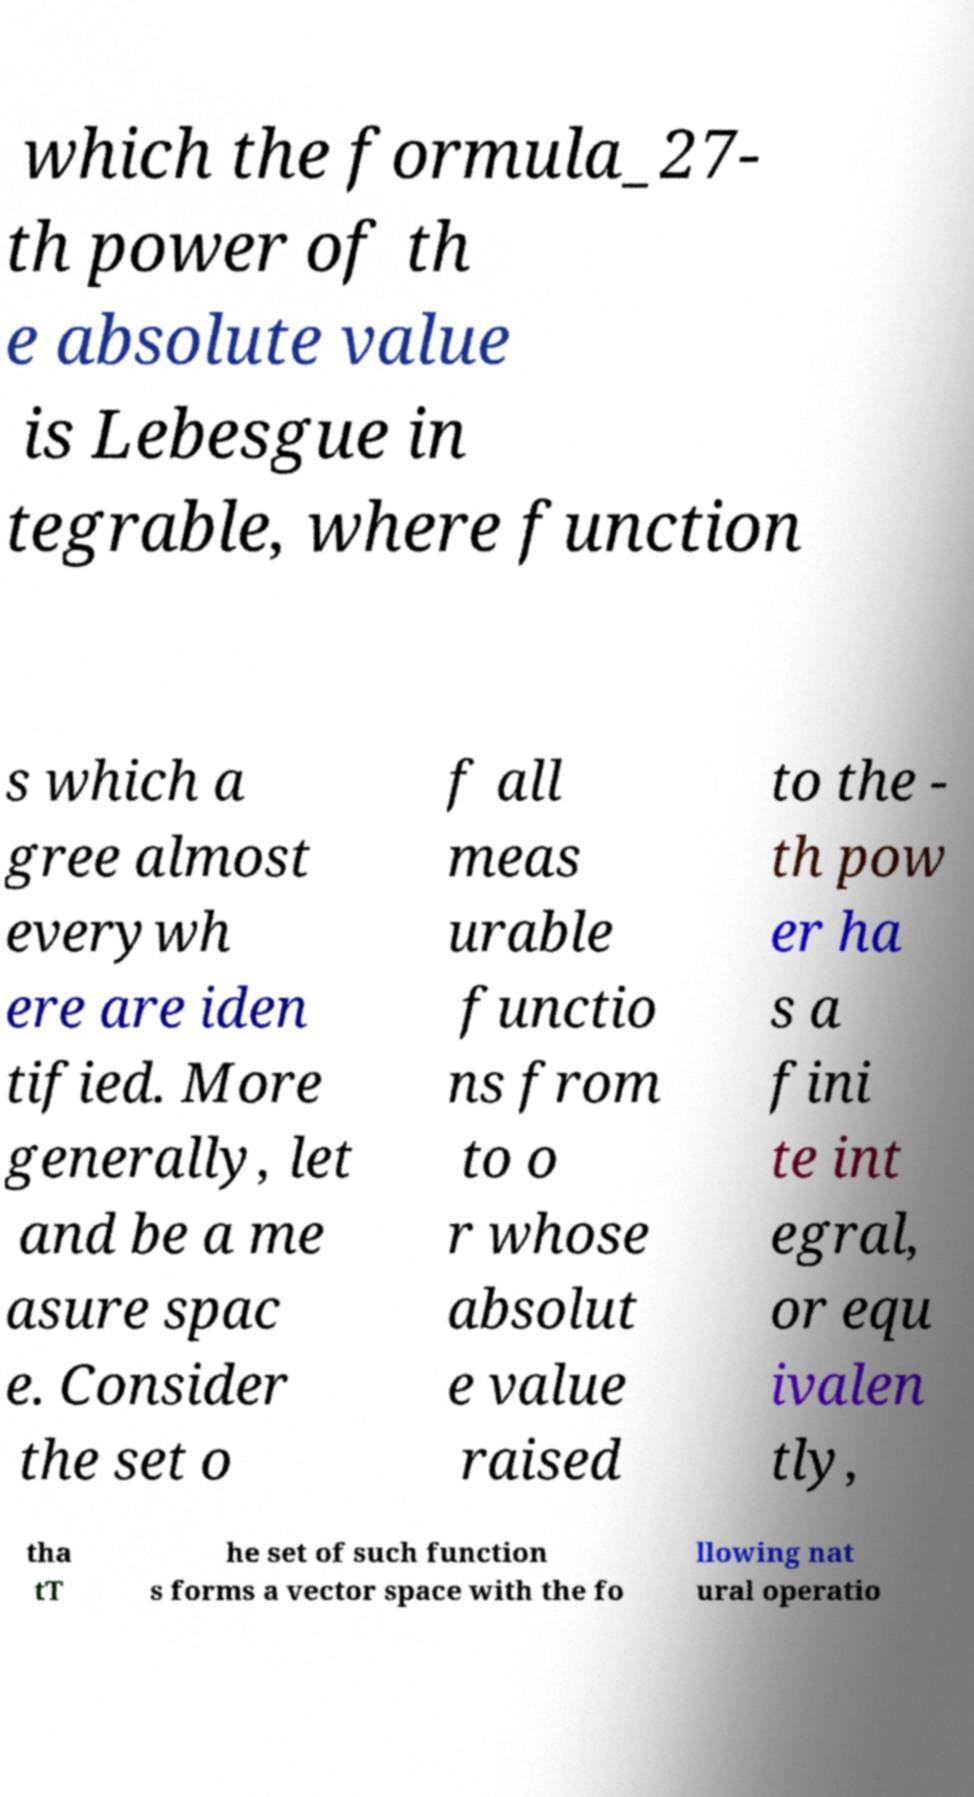Could you assist in decoding the text presented in this image and type it out clearly? which the formula_27- th power of th e absolute value is Lebesgue in tegrable, where function s which a gree almost everywh ere are iden tified. More generally, let and be a me asure spac e. Consider the set o f all meas urable functio ns from to o r whose absolut e value raised to the - th pow er ha s a fini te int egral, or equ ivalen tly, tha tT he set of such function s forms a vector space with the fo llowing nat ural operatio 